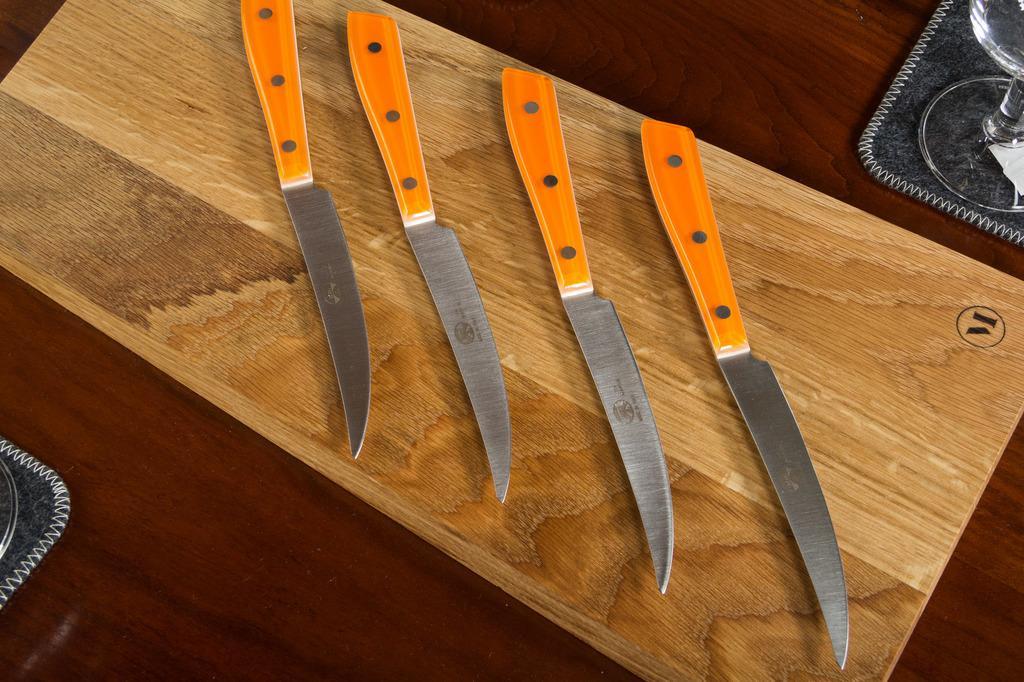Please provide a concise description of this image. In this image, we can see the wooden surface with some objects like knives. We can also see a glass and an object in the top right corner. We can also see an object on the left. 